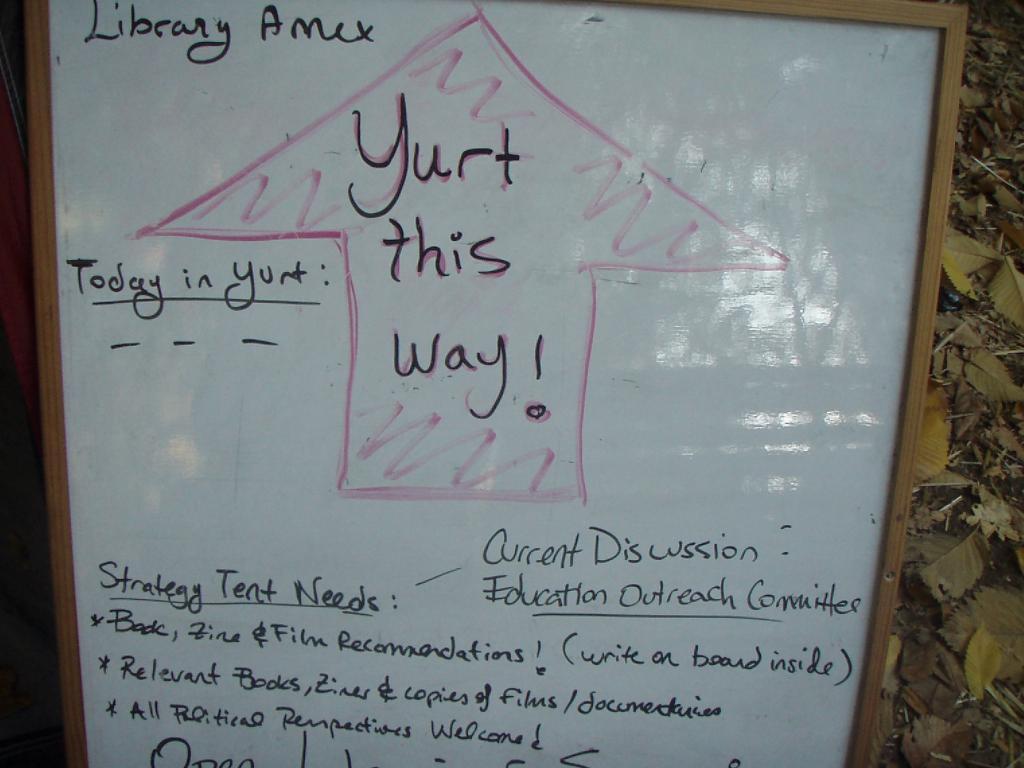What is this way?
Offer a terse response. Yurt. What is the current discussion about?
Make the answer very short. Education outreach committee. 